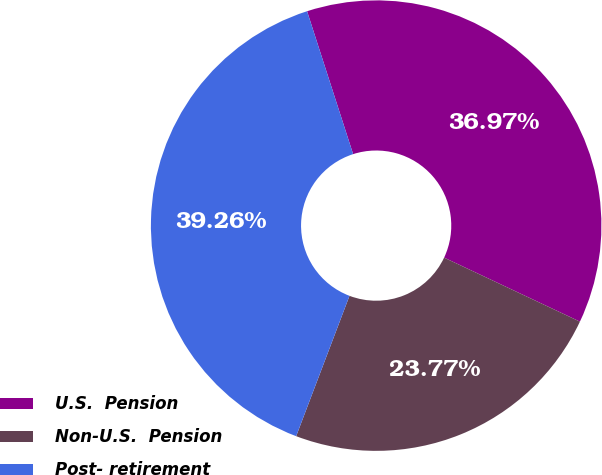Convert chart. <chart><loc_0><loc_0><loc_500><loc_500><pie_chart><fcel>U.S.  Pension<fcel>Non-U.S.  Pension<fcel>Post- retirement<nl><fcel>36.97%<fcel>23.77%<fcel>39.26%<nl></chart> 